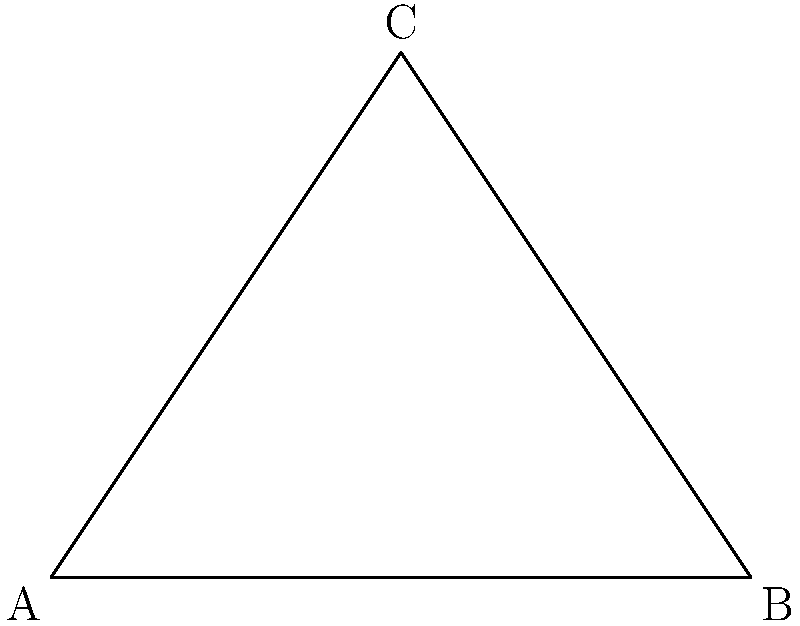In designing a protective helmet for extreme sports, the visor needs to cover a specific angle for optimal protection. If the visor forms a triangle ABC as shown, where angle BAC is 60° and angle ABC is 90°, what is the measure of angle BCA to ensure maximum coverage while maintaining visibility? Let's approach this step-by-step:

1) In any triangle, the sum of all internal angles is always 180°.

2) We are given two angles in the triangle:
   - Angle BAC = 60°
   - Angle ABC = 90° (right angle)

3) Let's call the unknown angle BCA as x°.

4) We can set up an equation based on the fact that all angles in a triangle sum to 180°:
   
   $60° + 90° + x° = 180°$

5) Simplify:
   
   $150° + x° = 180°$

6) Subtract 150° from both sides:
   
   $x° = 180° - 150° = 30°$

Therefore, angle BCA must be 30° to complete the triangle and ensure maximum coverage while maintaining visibility for the extreme sports helmet visor.
Answer: 30° 